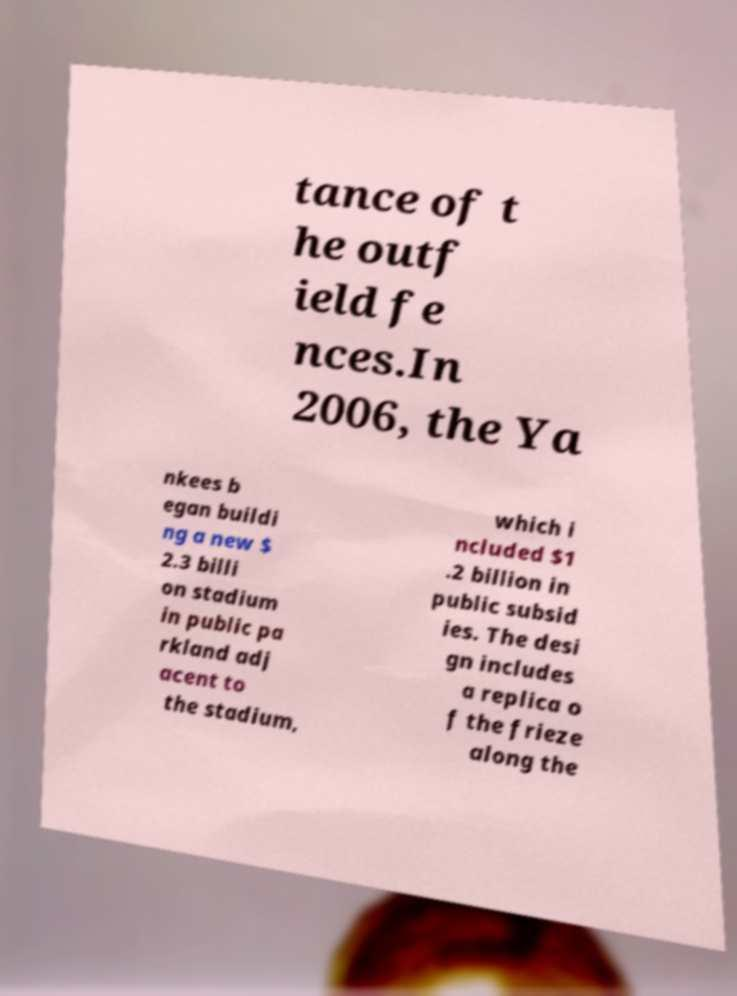Can you accurately transcribe the text from the provided image for me? tance of t he outf ield fe nces.In 2006, the Ya nkees b egan buildi ng a new $ 2.3 billi on stadium in public pa rkland adj acent to the stadium, which i ncluded $1 .2 billion in public subsid ies. The desi gn includes a replica o f the frieze along the 